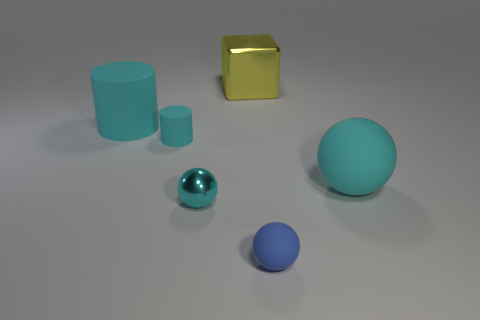Add 4 brown rubber balls. How many objects exist? 10 Subtract all cylinders. How many objects are left? 4 Subtract 0 red blocks. How many objects are left? 6 Subtract all tiny rubber objects. Subtract all rubber things. How many objects are left? 0 Add 2 big yellow shiny blocks. How many big yellow shiny blocks are left? 3 Add 2 big green spheres. How many big green spheres exist? 2 